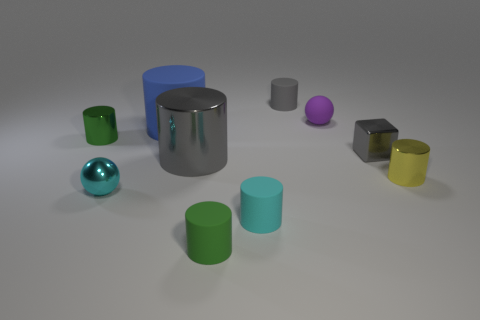What number of cylinders are brown shiny objects or gray metal objects?
Provide a succinct answer. 1. What color is the rubber ball that is the same size as the cyan shiny sphere?
Offer a very short reply. Purple. The small purple rubber thing behind the cyan shiny thing that is in front of the small green metallic thing is what shape?
Your response must be concise. Sphere. Is the size of the green object that is behind the cube the same as the tiny gray rubber cylinder?
Offer a very short reply. Yes. How many other things are made of the same material as the cube?
Offer a terse response. 4. How many brown things are shiny cylinders or big cylinders?
Provide a short and direct response. 0. What size is the shiny object that is the same color as the tiny cube?
Ensure brevity in your answer.  Large. There is a blue cylinder; how many purple objects are on the left side of it?
Make the answer very short. 0. There is a gray cylinder that is in front of the green cylinder that is behind the small cyan thing that is behind the cyan matte cylinder; what is its size?
Your response must be concise. Large. There is a tiny purple matte ball behind the cylinder that is right of the purple object; are there any gray things to the left of it?
Provide a short and direct response. Yes. 